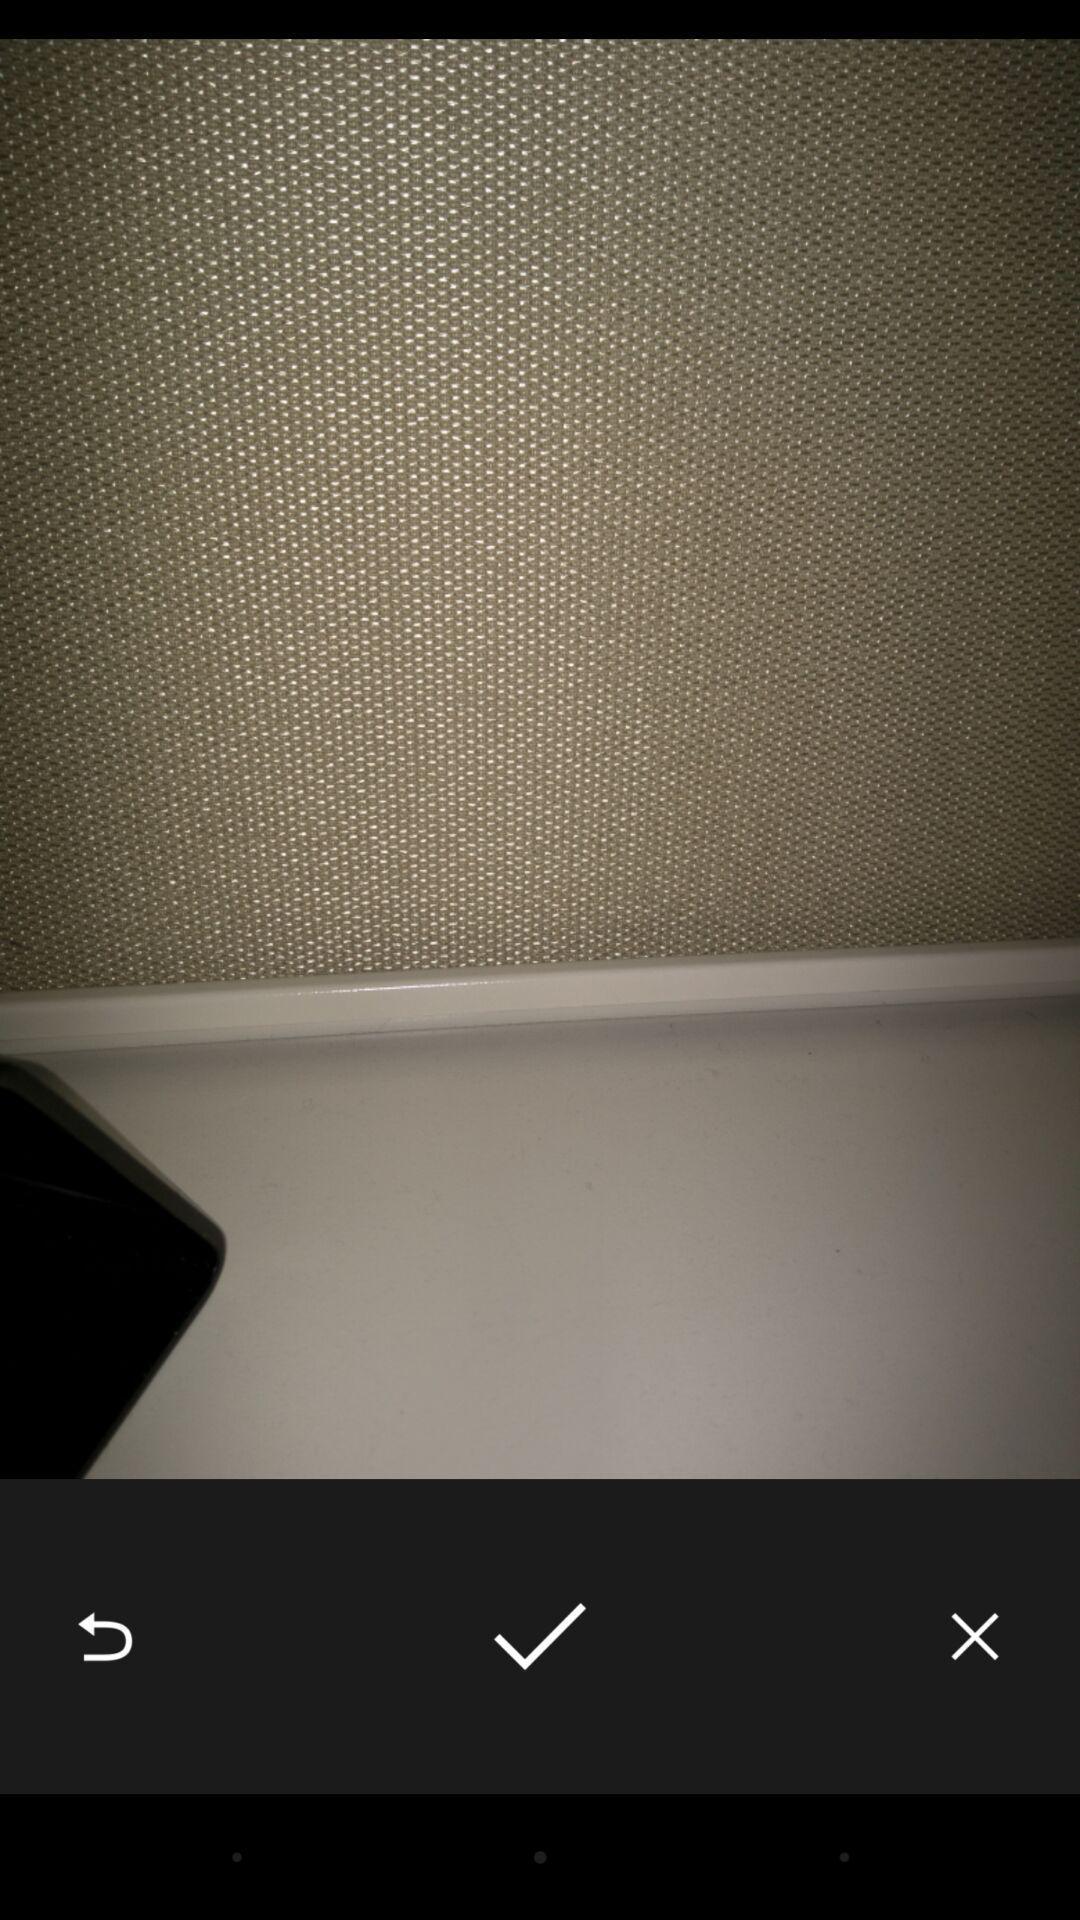What is the overall content of this screenshot? Screen displaying an image with multiple controls. 